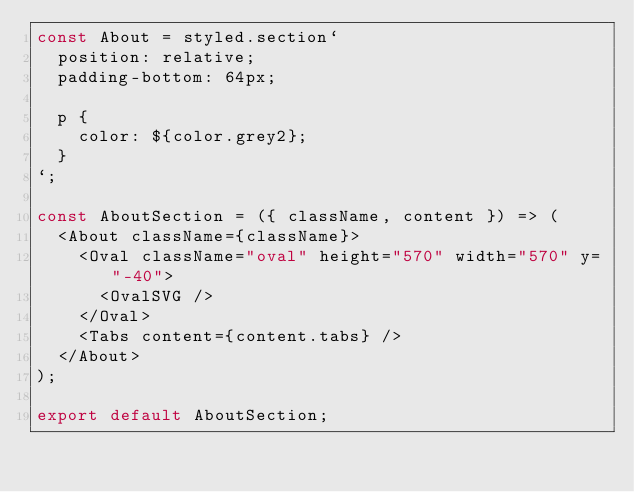Convert code to text. <code><loc_0><loc_0><loc_500><loc_500><_JavaScript_>const About = styled.section`
  position: relative;
  padding-bottom: 64px;

  p {
    color: ${color.grey2};
  }
`;

const AboutSection = ({ className, content }) => (
  <About className={className}>
    <Oval className="oval" height="570" width="570" y="-40">
      <OvalSVG />
    </Oval>
    <Tabs content={content.tabs} />
  </About>
);

export default AboutSection;
</code> 